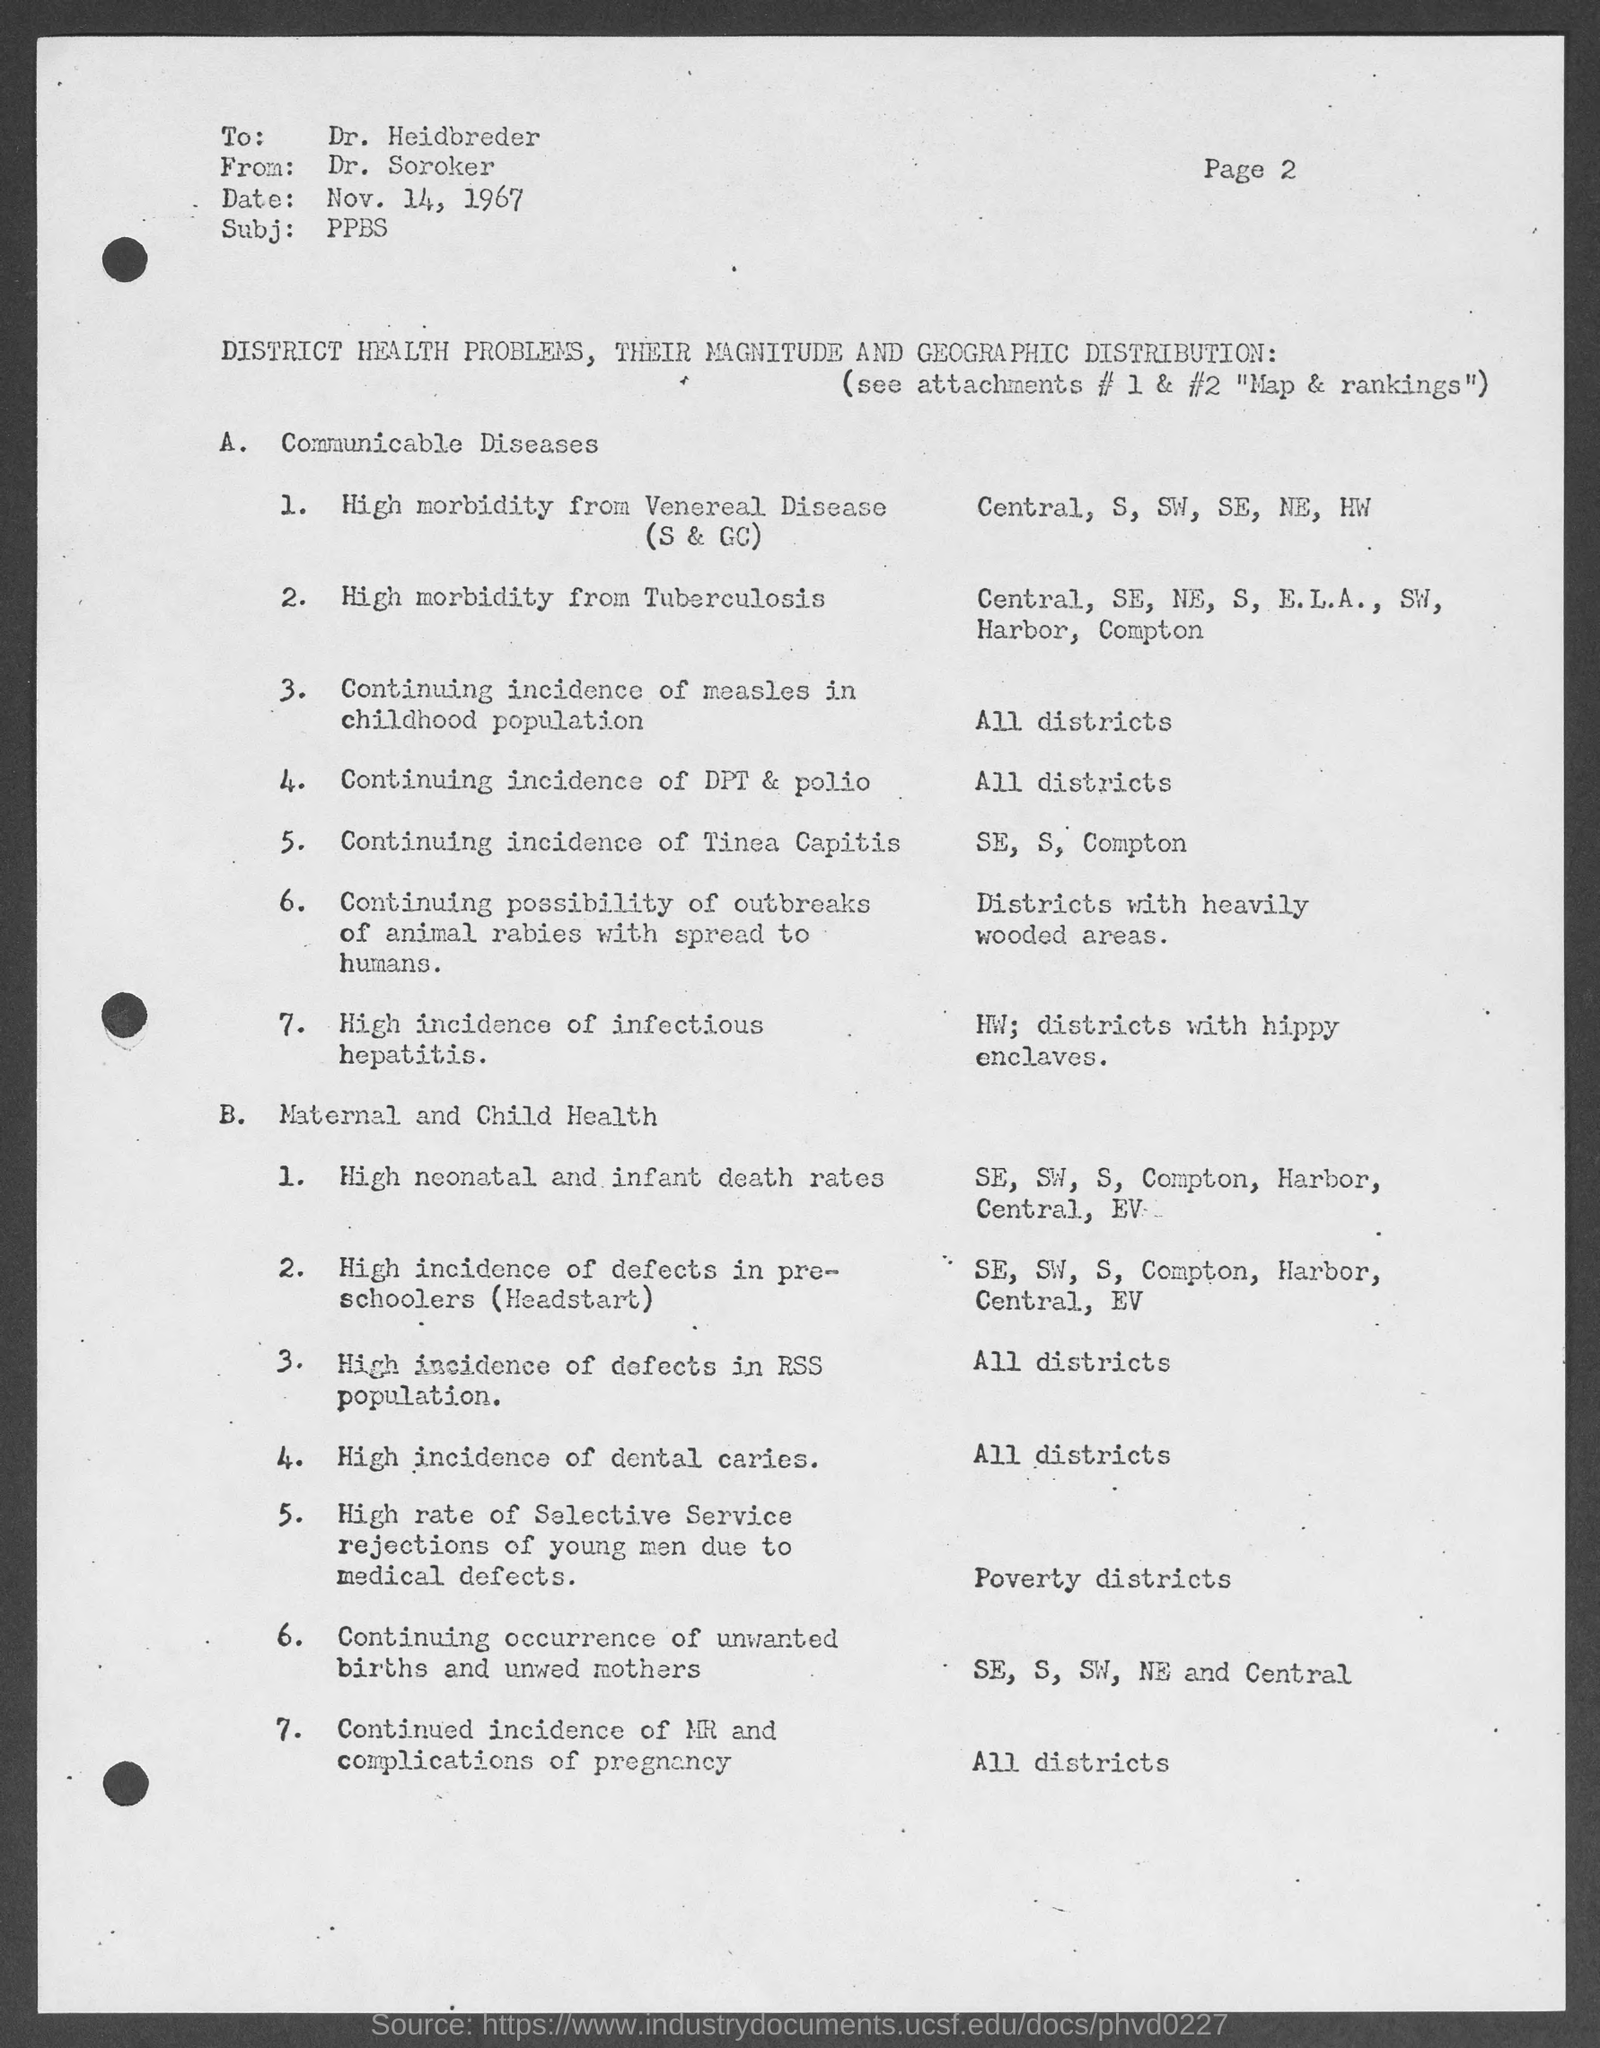What is the page no mentioned in this document?
Offer a terse response. Page 2. What is the date mentioned in this document?
Your answer should be very brief. Nov. 14, 1967. Who is the receiver of this document?
Your answer should be compact. Dr. Heidbreder. What is the subject mentioned in the document?
Give a very brief answer. PPBS. Who is the sender of this document?
Your answer should be very brief. Dr. Soroker. What is the topic discussed in subheading A.?
Your response must be concise. A.    Communicable Diseases. 